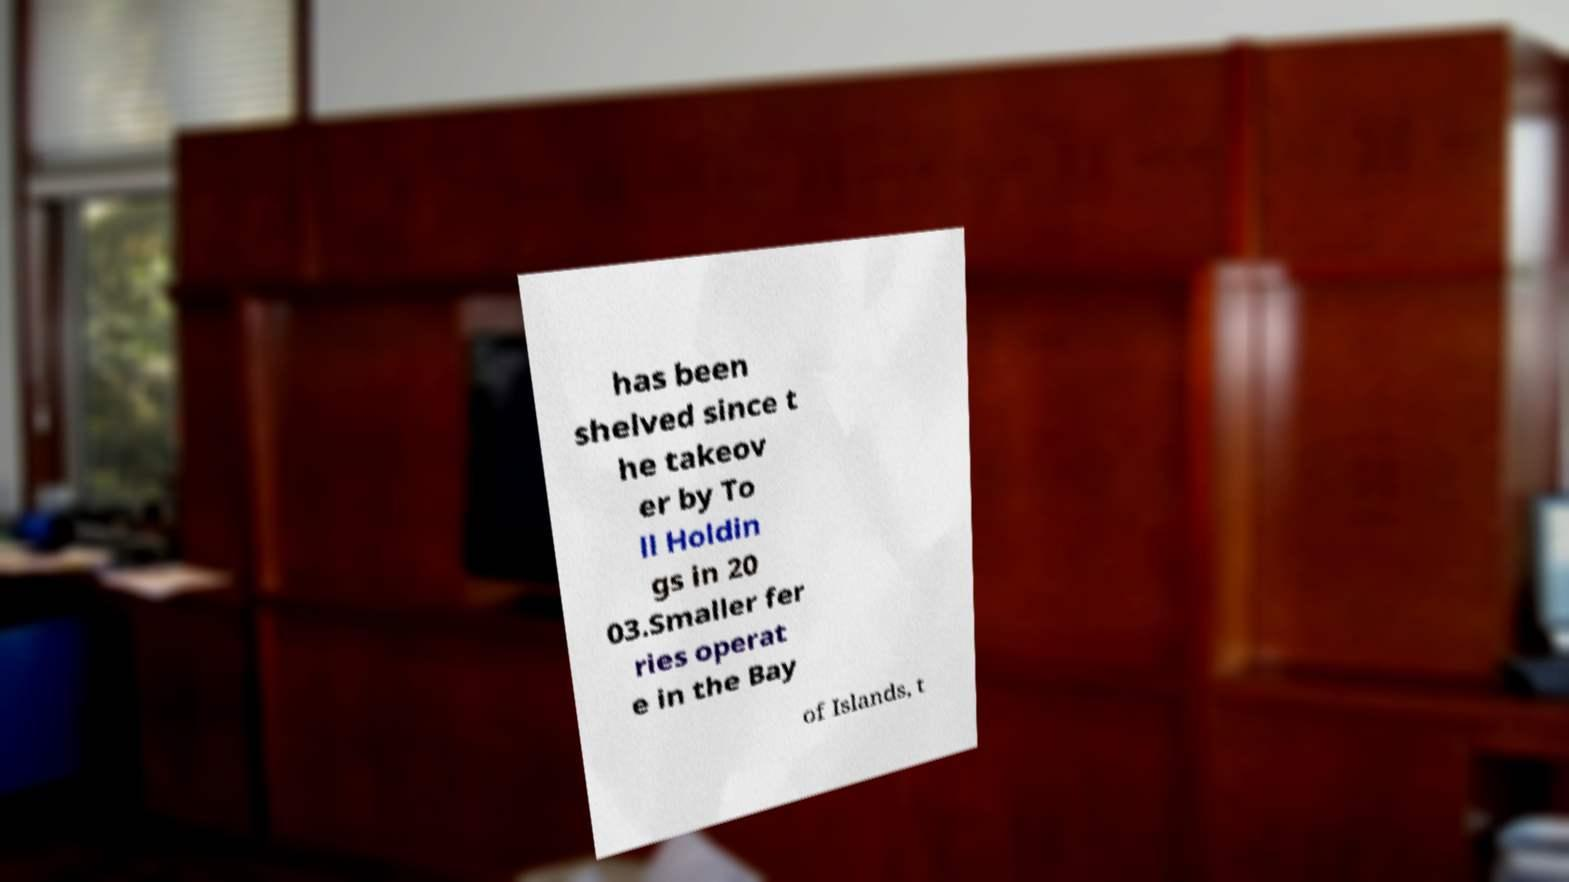Please identify and transcribe the text found in this image. has been shelved since t he takeov er by To ll Holdin gs in 20 03.Smaller fer ries operat e in the Bay of Islands, t 